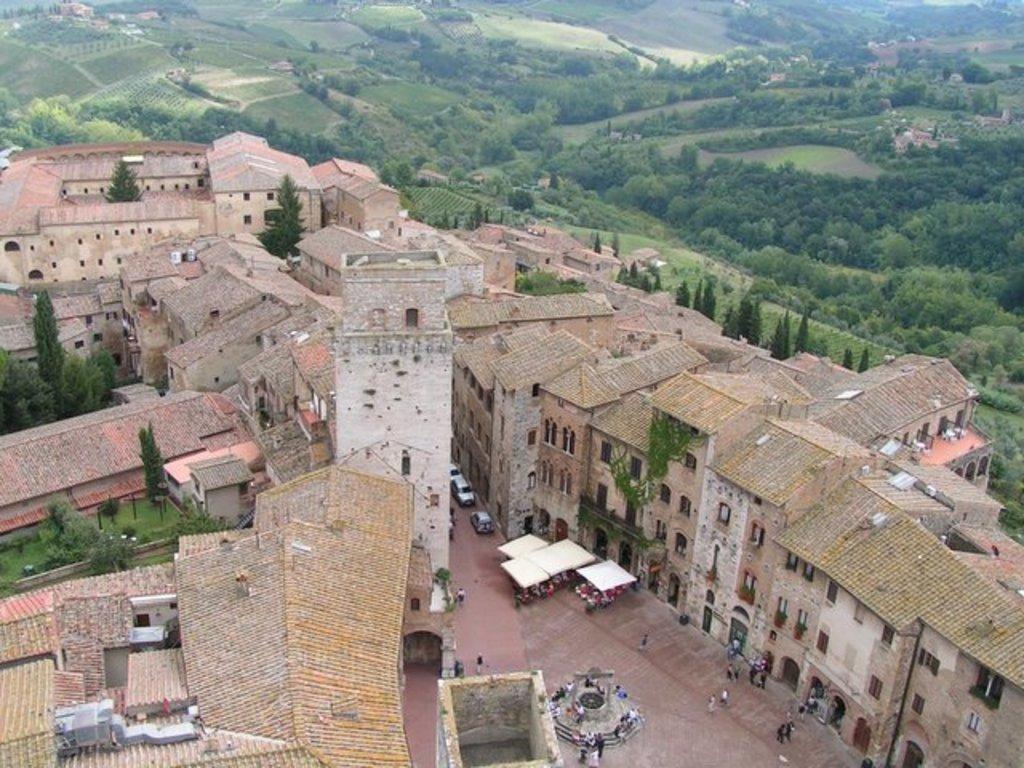Can you describe this image briefly? Here we can see buildings, trees, grass, vehicles and people. These are tents. To these buildings there are windows and doors.  